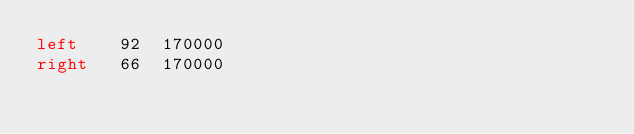<code> <loc_0><loc_0><loc_500><loc_500><_SQL_>left	92	170000
right	66	170000
</code> 